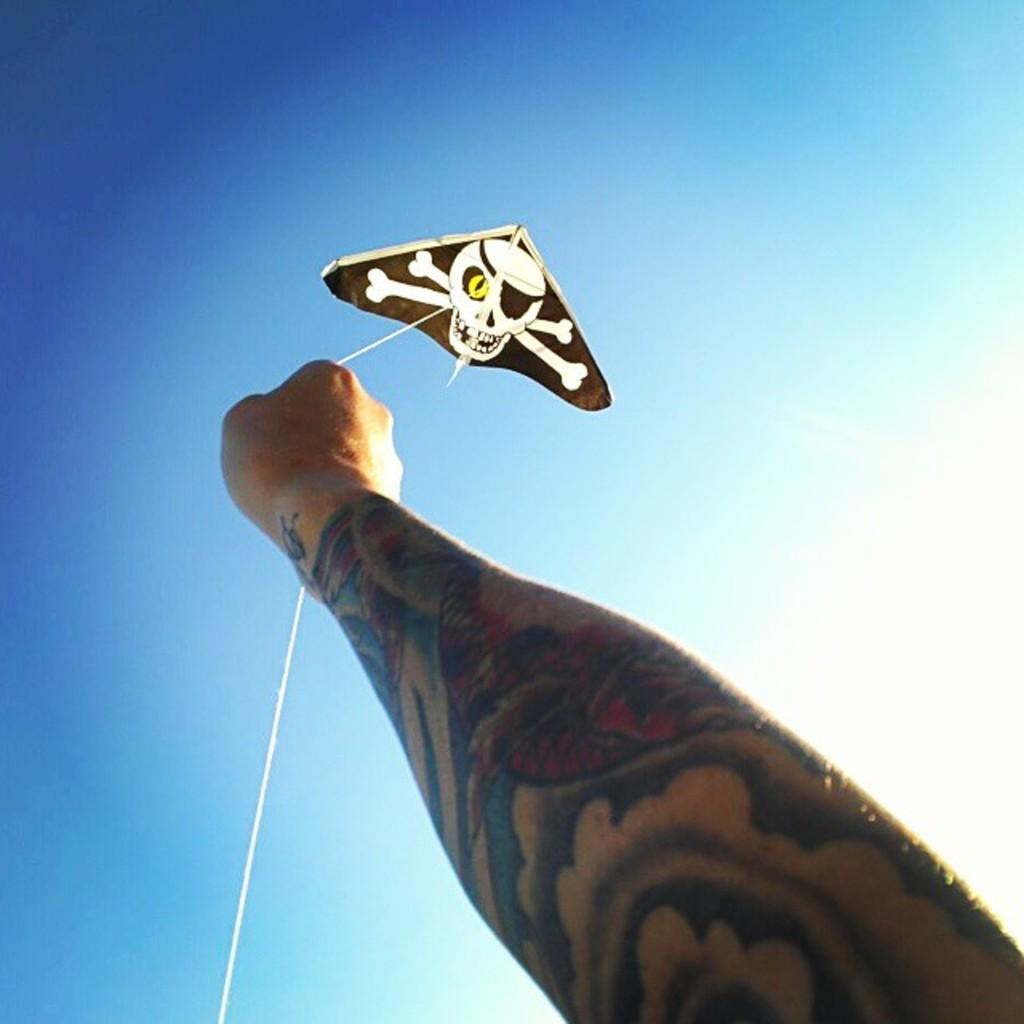What is the person's hand doing in the image? The hand is flying a kite in the image. How is the kite connected to the hand? The kite is connected to the hand with a thread. What can be seen on the person's hand? There is a tattoo on the hand. What is visible in the background of the image? The sky is visible in the background of the image. How many units of currency can be seen in the image? There is no currency visible in the image; it features a person's hand flying a kite with a tattoo and a kite connected by a thread. What type of writer is depicted in the image? There is no writer present in the image; it features a person's hand flying a kite with a tattoo and a kite connected by a thread. 